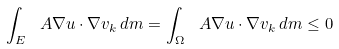<formula> <loc_0><loc_0><loc_500><loc_500>\int _ { E } \ A \nabla u \cdot \nabla v _ { k } \, d m = \int _ { \Omega } \ A \nabla u \cdot \nabla v _ { k } \, d m \leq 0</formula> 